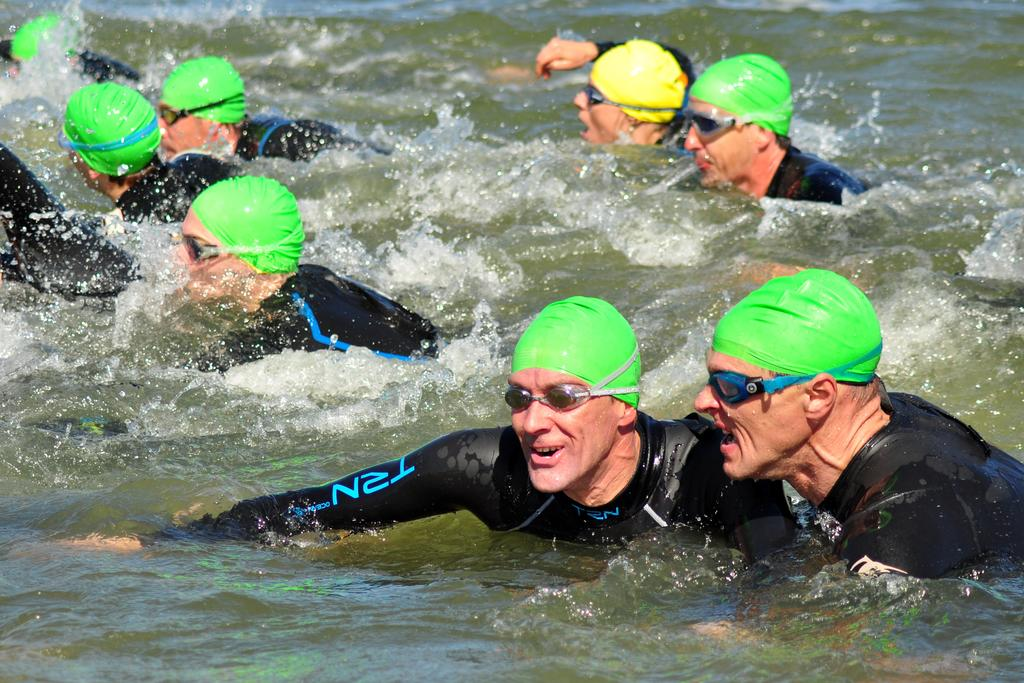What is the main element present in the image? There is water in the image. What are the people in the image doing? The people are in the water. What type of clothing are the people wearing? The people are wearing swimming costumes, swimming caps, and swimming glasses. What type of coat is the daughter wearing in the image? There is no daughter present in the image, and no coats are visible. 